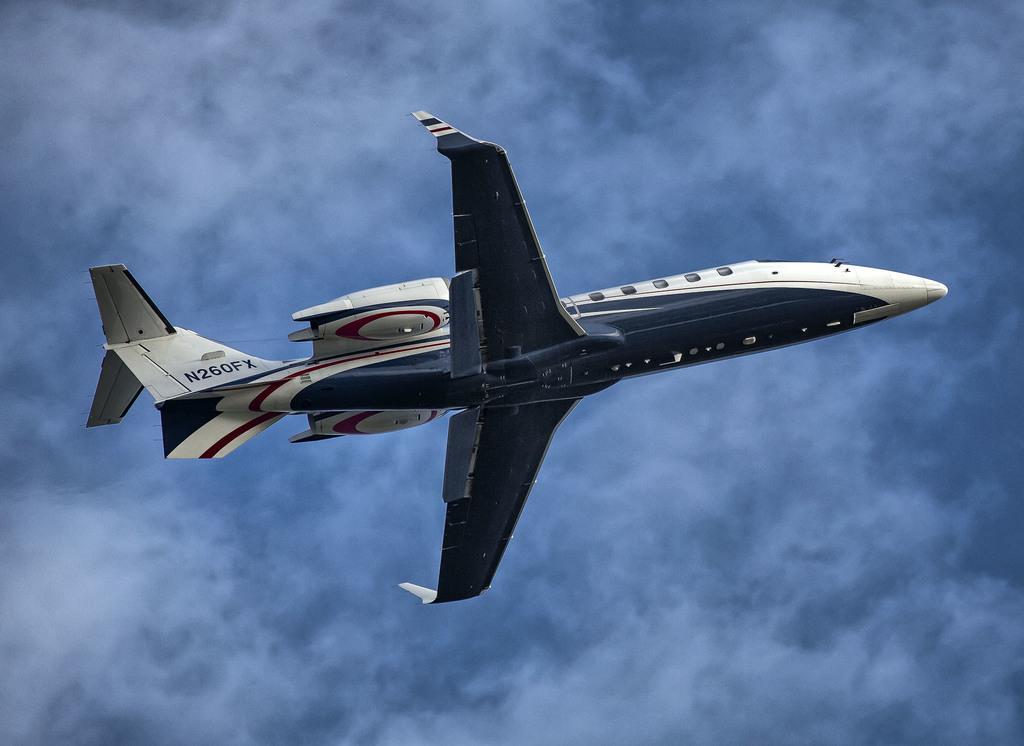How would you summarize this image in a sentence or two? In the center of the image there is a aeroplane. In the background of the image there is sky. 